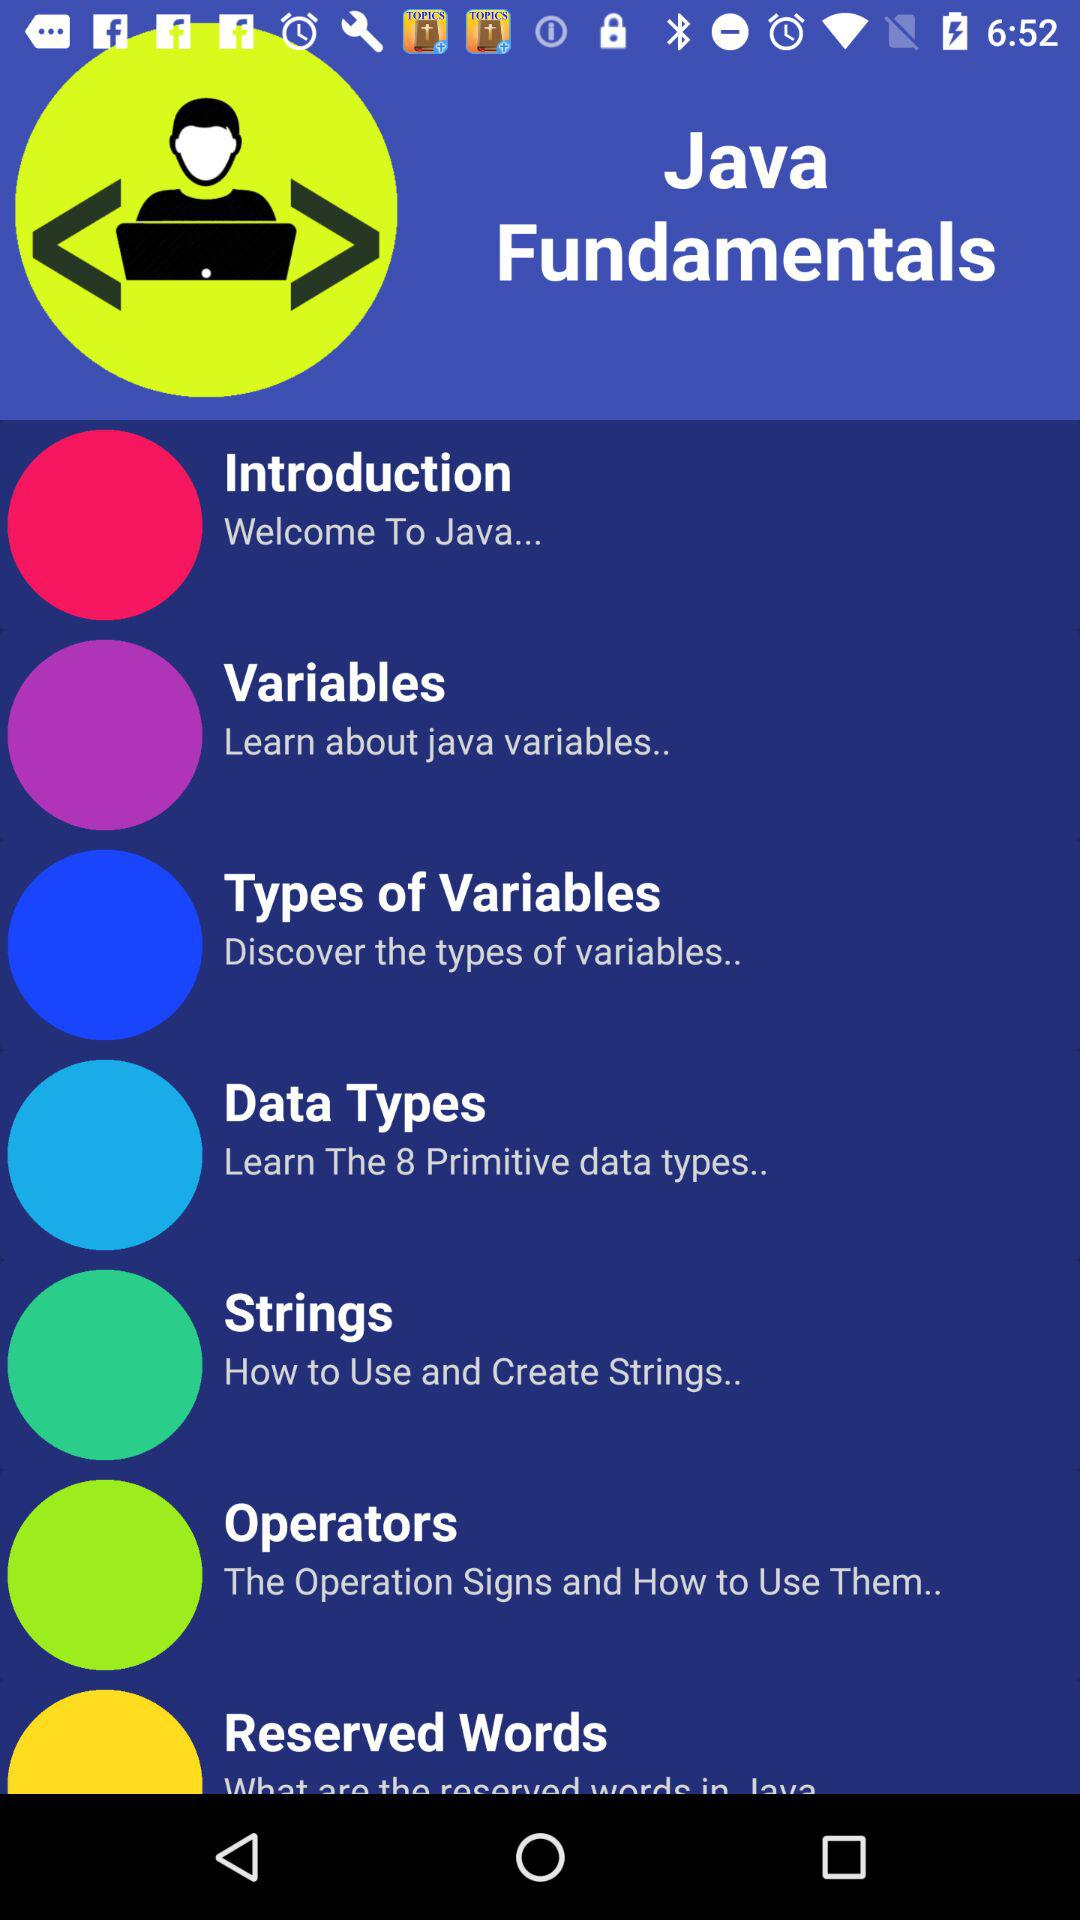How many primitive data types are there? There are 8 primitive data types. 